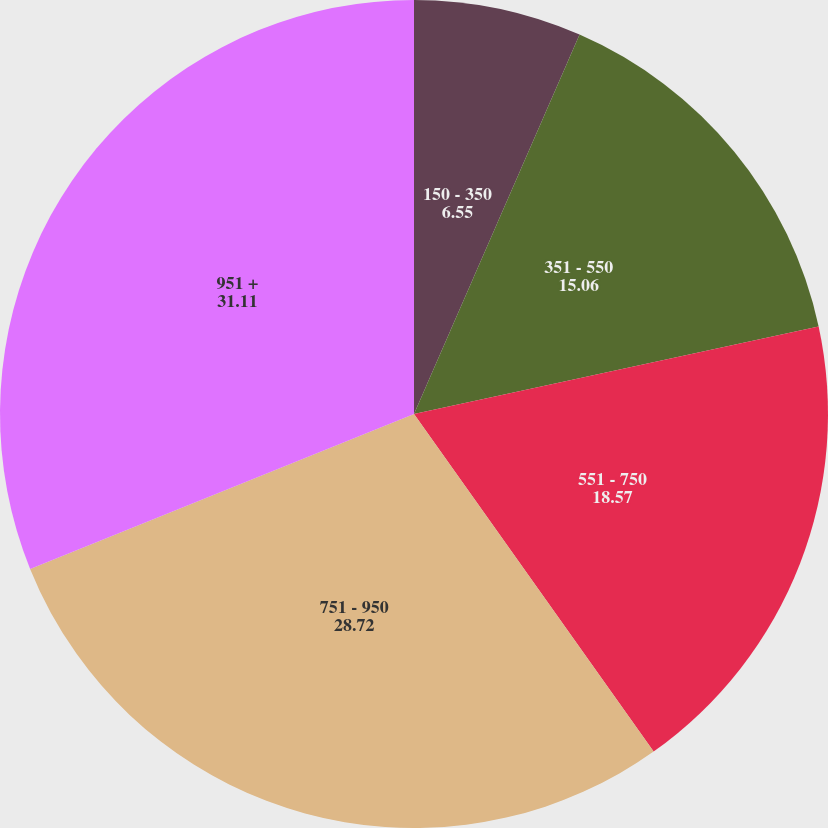Convert chart. <chart><loc_0><loc_0><loc_500><loc_500><pie_chart><fcel>150 - 350<fcel>351 - 550<fcel>551 - 750<fcel>751 - 950<fcel>951 +<nl><fcel>6.55%<fcel>15.06%<fcel>18.57%<fcel>28.72%<fcel>31.11%<nl></chart> 